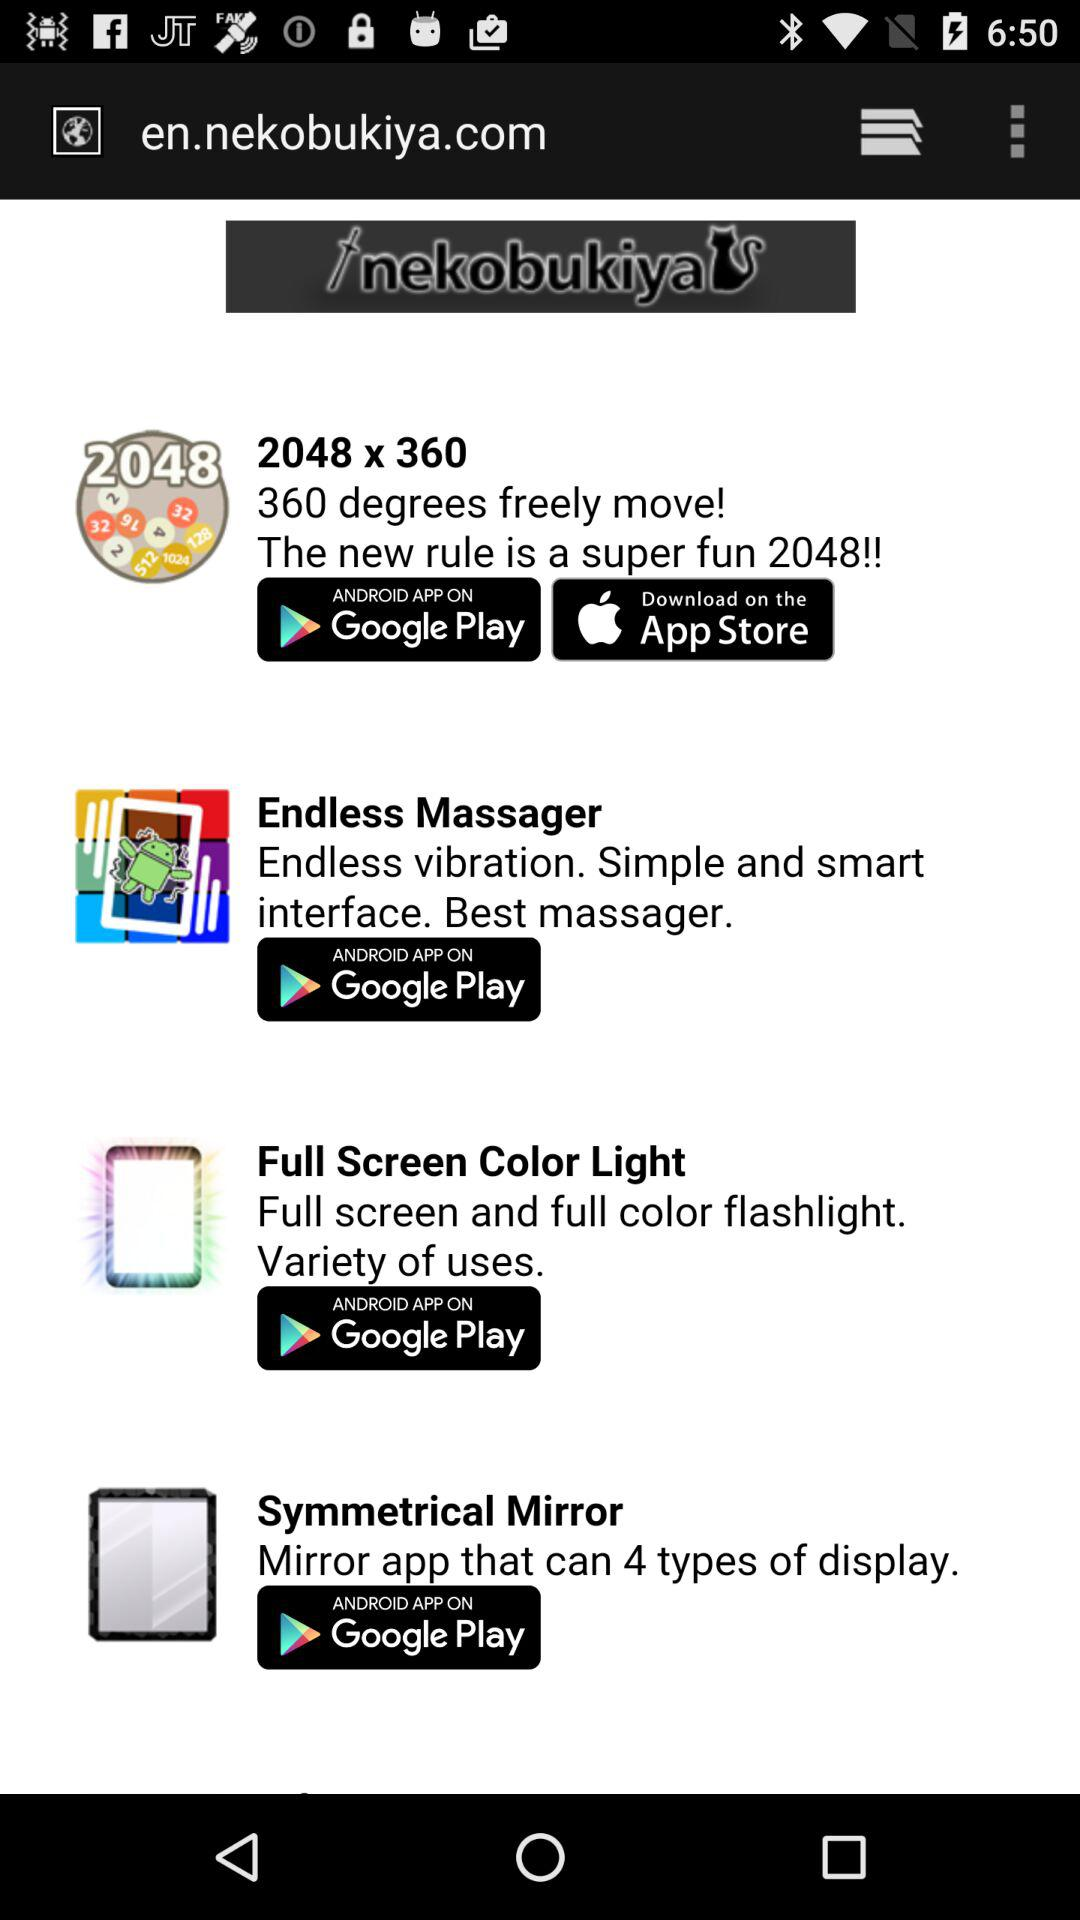What app has four types of display? The app is "Symmetrical Mirror". 